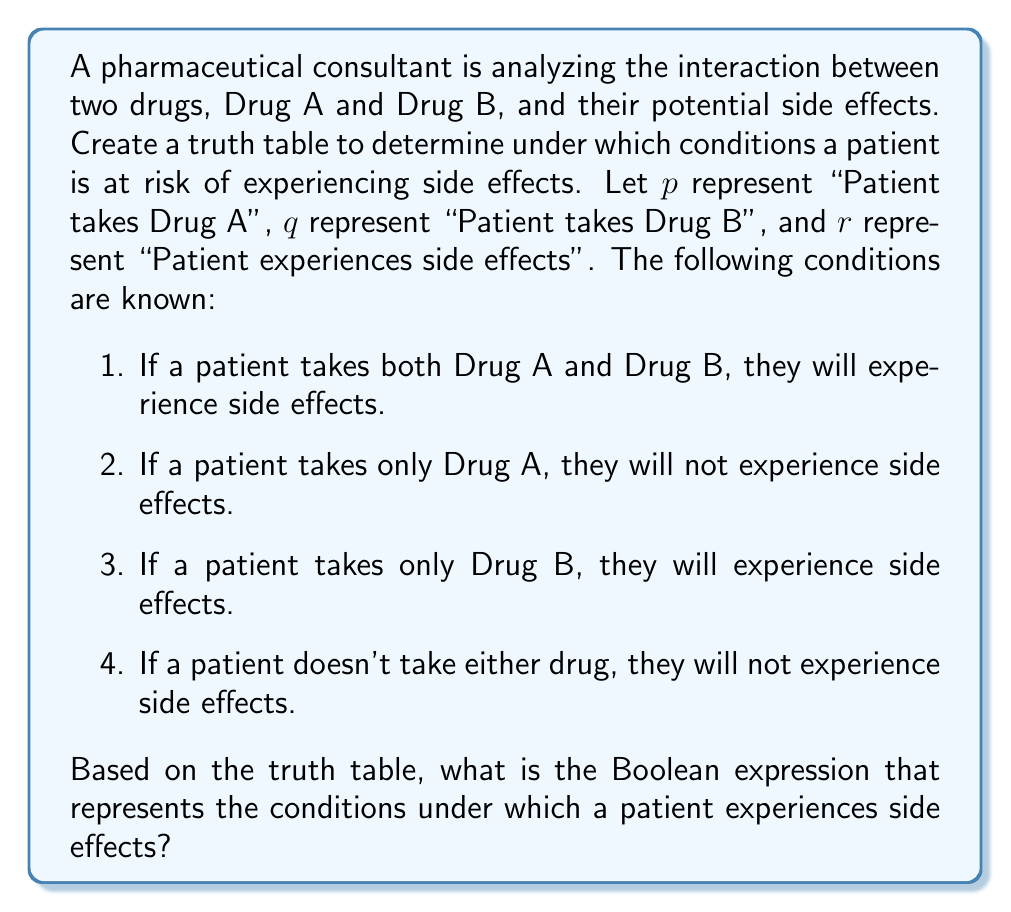What is the answer to this math problem? Let's approach this step-by-step:

1. First, we need to create a truth table with three variables: $p$, $q$, and $r$.

2. The truth table will have $2^3 = 8$ rows, representing all possible combinations of the variables.

3. We'll fill in the $r$ column based on the given conditions:

   $$
   \begin{array}{|c|c|c|}
   \hline
   p & q & r \\
   \hline
   0 & 0 & 0 \\
   0 & 1 & 1 \\
   1 & 0 & 0 \\
   1 & 1 & 1 \\
   \hline
   \end{array}
   $$

4. Now, we need to find a Boolean expression that matches this truth table for $r$.

5. We can use the sum-of-products method. We'll include each row where $r = 1$:

   $r = (\overline{p} \cdot q) + (p \cdot q)$

6. This can be simplified using Boolean algebra:

   $r = (\overline{p} \cdot q) + (p \cdot q)$
   $r = q \cdot (\overline{p} + p)$
   $r = q \cdot 1$
   $r = q$

7. Therefore, the simplified Boolean expression for experiencing side effects is simply $q$, which means "Patient takes Drug B".
Answer: $r = q$ 